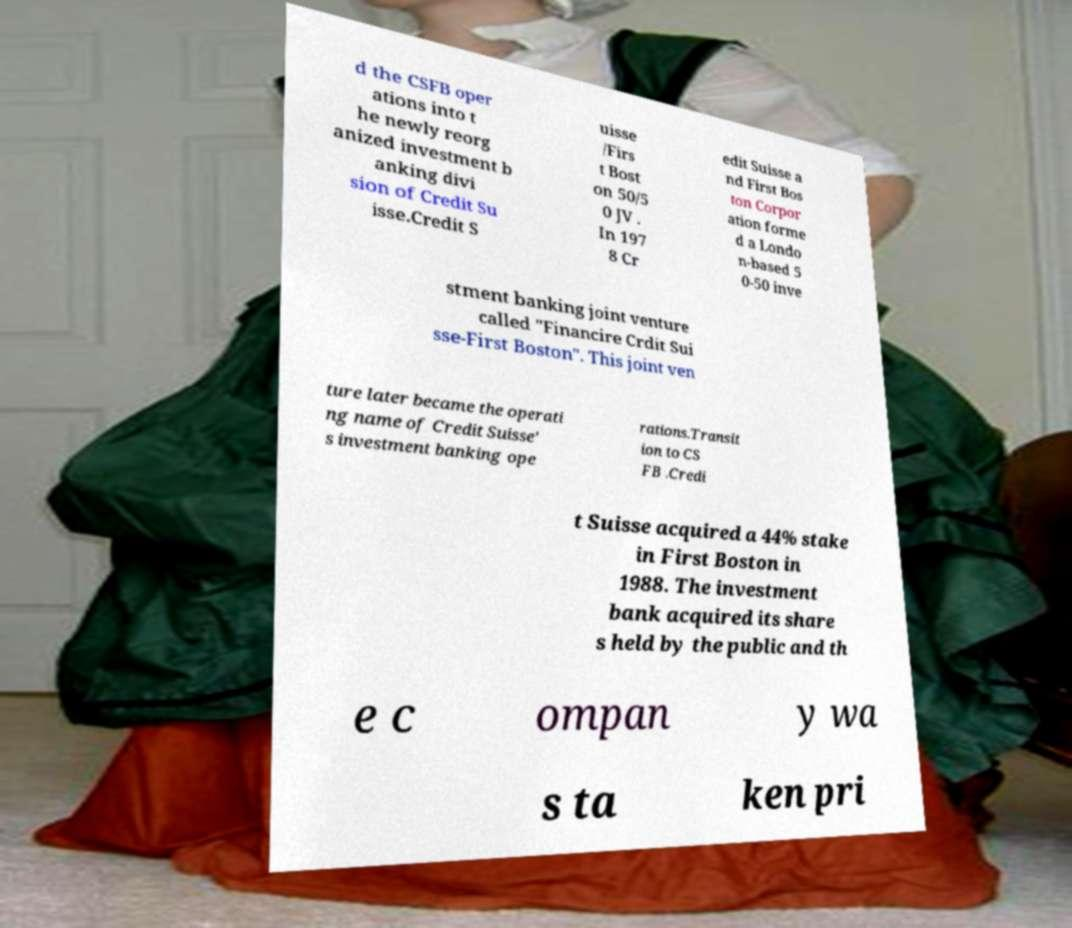I need the written content from this picture converted into text. Can you do that? d the CSFB oper ations into t he newly reorg anized investment b anking divi sion of Credit Su isse.Credit S uisse /Firs t Bost on 50/5 0 JV . In 197 8 Cr edit Suisse a nd First Bos ton Corpor ation forme d a Londo n-based 5 0-50 inve stment banking joint venture called "Financire Crdit Sui sse-First Boston". This joint ven ture later became the operati ng name of Credit Suisse' s investment banking ope rations.Transit ion to CS FB .Credi t Suisse acquired a 44% stake in First Boston in 1988. The investment bank acquired its share s held by the public and th e c ompan y wa s ta ken pri 